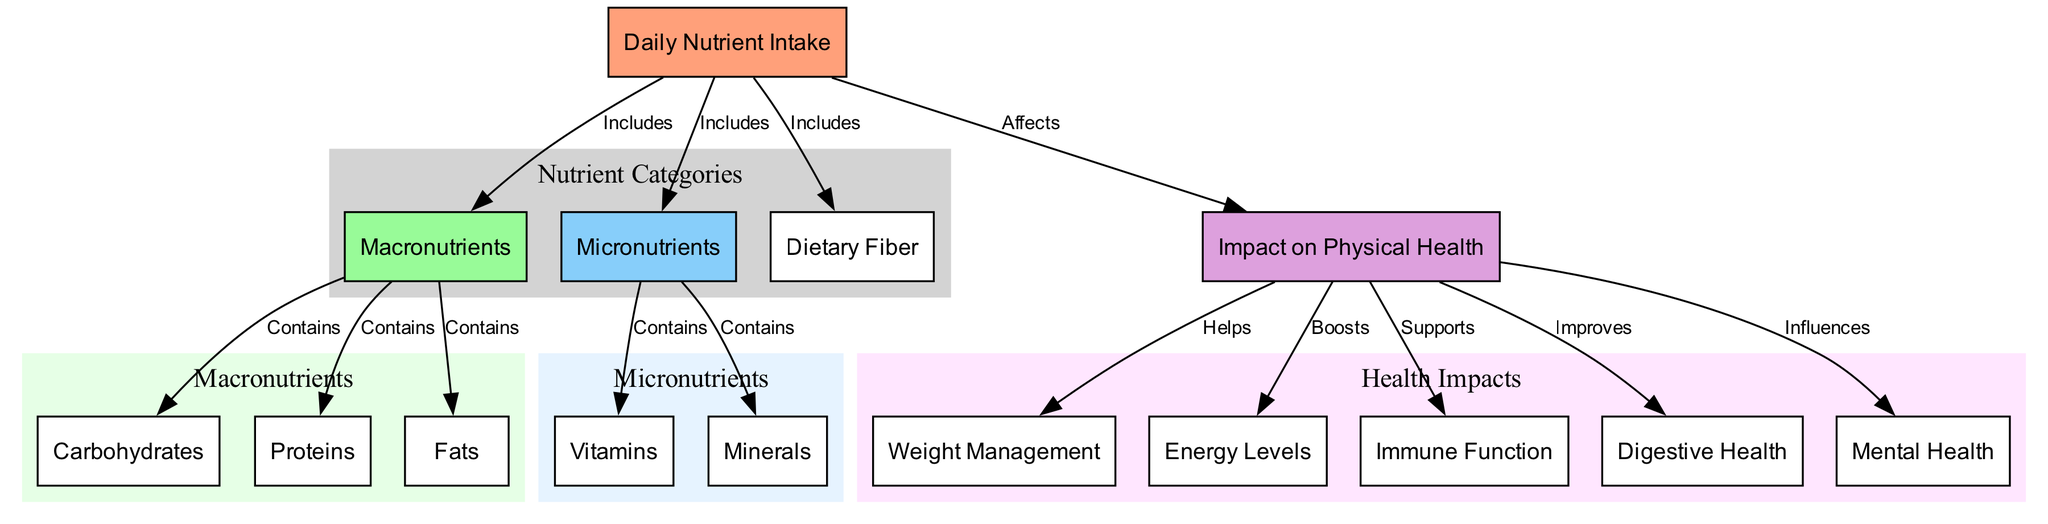What are the two main categories of nutrients shown in the diagram? The diagram presents two primary categories under "Daily Nutrient Intake": Macronutrients and Micronutrients. These categories contain further subdivisions.
Answer: Macronutrients and Micronutrients How many nodes are there in total in the diagram? By counting all nodes listed, there are 15 unique nodes present in the diagram: Daily Nutrient Intake, Macronutrients, Micronutrients, Carbohydrates, Proteins, Fats, Vitamins, Minerals, Dietary Fiber, Impact on Physical Health, Weight Management, Energy Levels, Immune Function, Digestive Health, and Mental Health.
Answer: 15 What is one outcome of "Daily Nutrient Intake" according to the diagram? The diagram indicates that "Daily Nutrient Intake" leads to "Impact on Physical Health". This relationship is signified by the edge stating that it "Affects" the physical health impacts.
Answer: Impact on Physical Health Which macronutrient is related to weight management? The diagram shows that "Weight Management" is directly connected to "Impact on Physical Health," which arises from "Daily Nutrient Intake," making this nutrient category crucial to the outcome.
Answer: Weight Management How do micronutrients influence overall health? The diagram illustrates that "Micronutrients" (Vitamins and Minerals) are subcategories that contribute to the "Daily Nutrient Intake", which, in turn, influences multiple aspects of overall health including energy levels and immune function.
Answer: By supporting health What specific micronutrient is linked to supporting immune function? The "Immune Function" node connects back to "Daily Nutrient Intake," indicating that micronutrients (Vitamins and Minerals) play roles in impacting immune health, as hinted by their broader health connections.
Answer: Vitamins and Minerals What does dietary fiber impact according to the diagram? Dietary Fiber is included under “Daily Nutrient Intake”, and while it does not connect directly to a specific health outcome in the diagram, it generally is known to influence aspects such as Digestive Health, which is connected to Physical Health impacts.
Answer: Digestive Health Which nutrient can boost energy levels? The connection from "Daily Nutrient Intake" to "Energy Levels" suggests that proper intake of all nutrients, especially macronutrients, is essential for boosting one's energy levels according to the visual relationships shown in the diagram.
Answer: Energy Levels 